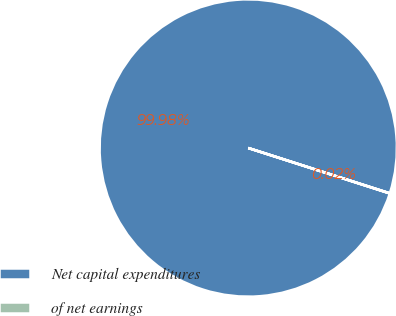<chart> <loc_0><loc_0><loc_500><loc_500><pie_chart><fcel>Net capital expenditures<fcel>of net earnings<nl><fcel>99.98%<fcel>0.02%<nl></chart> 